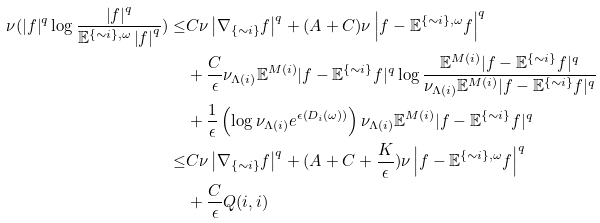Convert formula to latex. <formula><loc_0><loc_0><loc_500><loc_500>\nu ( \left | f \right | ^ { q } \log \frac { \left | f \right | ^ { q } } { \mathbb { E } ^ { \{ \sim i \} , \omega } \left | f \right | ^ { q } } ) \leq & C \nu \left | \nabla _ { \{ \sim i \} } f \right | ^ { q } + ( A + C ) \nu \left | f - \mathbb { E } ^ { \{ \sim i \} , \omega } f \right | ^ { q } \\ & + \frac { C } { \epsilon } \nu _ { \Lambda ( i ) } \mathbb { E } ^ { M ( i ) } | f - \mathbb { E } ^ { \{ \sim i \} } f | ^ { q } \log \frac { \mathbb { E } ^ { M ( i ) } | f - \mathbb { E } ^ { \{ \sim i \} } f | ^ { q } } { \nu _ { \Lambda ( i ) } \mathbb { E } ^ { M ( i ) } | f - \mathbb { E } ^ { \{ \sim i \} } f | ^ { q } } \\ & + \frac { 1 } { \epsilon } \left ( \log \nu _ { \Lambda ( i ) } e ^ { \epsilon \left ( D _ { i } ( \omega ) \right ) } \right ) \nu _ { \Lambda ( i ) } \mathbb { E } ^ { M ( i ) } | f - \mathbb { E } ^ { \{ \sim i \} } f | ^ { q } \\ \leq & C \nu \left | \nabla _ { \{ \sim i \} } f \right | ^ { q } + ( A + C + \frac { K } { \epsilon } ) \nu \left | f - \mathbb { E } ^ { \{ \sim i \} , \omega } f \right | ^ { q } \\ & + \frac { C } { \epsilon } Q ( i , i )</formula> 